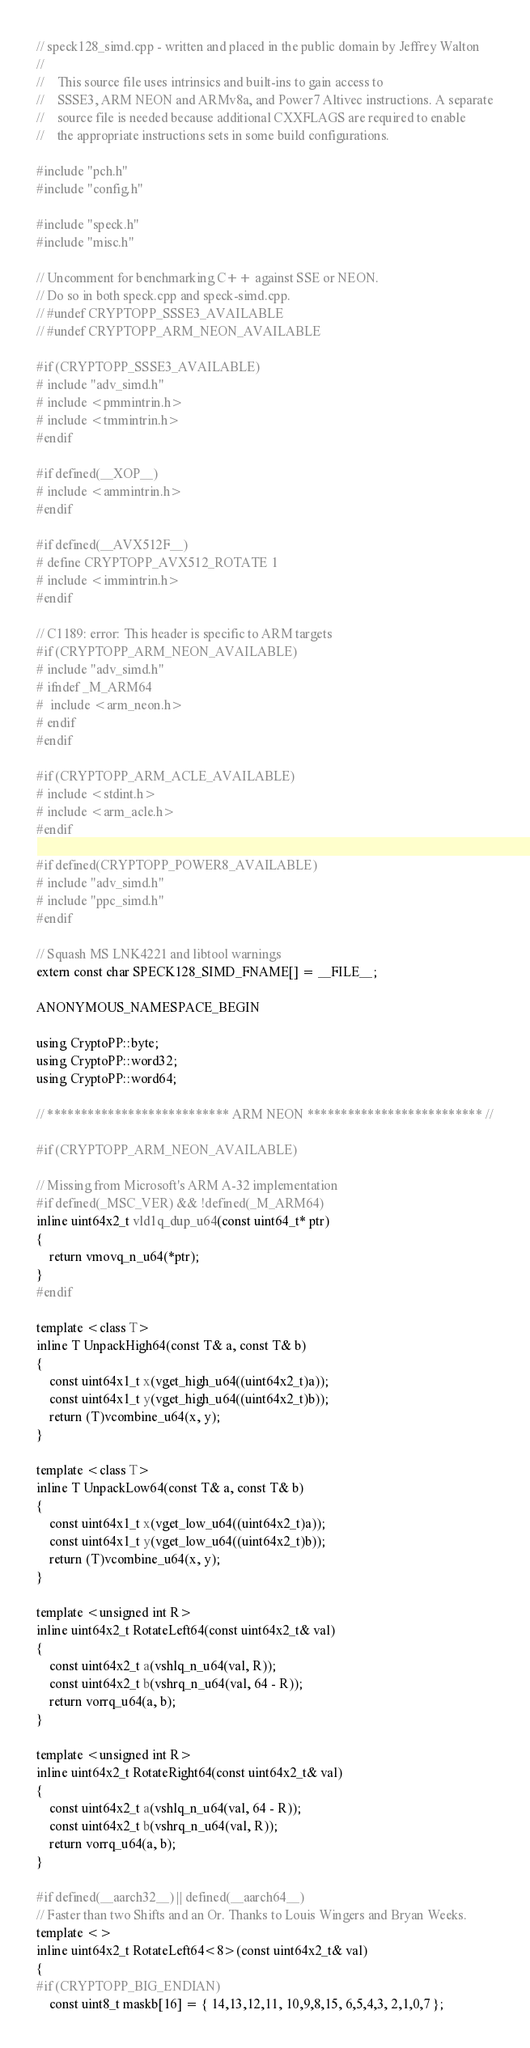<code> <loc_0><loc_0><loc_500><loc_500><_C++_>// speck128_simd.cpp - written and placed in the public domain by Jeffrey Walton
//
//    This source file uses intrinsics and built-ins to gain access to
//    SSSE3, ARM NEON and ARMv8a, and Power7 Altivec instructions. A separate
//    source file is needed because additional CXXFLAGS are required to enable
//    the appropriate instructions sets in some build configurations.

#include "pch.h"
#include "config.h"

#include "speck.h"
#include "misc.h"

// Uncomment for benchmarking C++ against SSE or NEON.
// Do so in both speck.cpp and speck-simd.cpp.
// #undef CRYPTOPP_SSSE3_AVAILABLE
// #undef CRYPTOPP_ARM_NEON_AVAILABLE

#if (CRYPTOPP_SSSE3_AVAILABLE)
# include "adv_simd.h"
# include <pmmintrin.h>
# include <tmmintrin.h>
#endif

#if defined(__XOP__)
# include <ammintrin.h>
#endif

#if defined(__AVX512F__)
# define CRYPTOPP_AVX512_ROTATE 1
# include <immintrin.h>
#endif

// C1189: error: This header is specific to ARM targets
#if (CRYPTOPP_ARM_NEON_AVAILABLE)
# include "adv_simd.h"
# ifndef _M_ARM64
#  include <arm_neon.h>
# endif
#endif

#if (CRYPTOPP_ARM_ACLE_AVAILABLE)
# include <stdint.h>
# include <arm_acle.h>
#endif

#if defined(CRYPTOPP_POWER8_AVAILABLE)
# include "adv_simd.h"
# include "ppc_simd.h"
#endif

// Squash MS LNK4221 and libtool warnings
extern const char SPECK128_SIMD_FNAME[] = __FILE__;

ANONYMOUS_NAMESPACE_BEGIN

using CryptoPP::byte;
using CryptoPP::word32;
using CryptoPP::word64;

// *************************** ARM NEON ************************** //

#if (CRYPTOPP_ARM_NEON_AVAILABLE)

// Missing from Microsoft's ARM A-32 implementation
#if defined(_MSC_VER) && !defined(_M_ARM64)
inline uint64x2_t vld1q_dup_u64(const uint64_t* ptr)
{
	return vmovq_n_u64(*ptr);
}
#endif

template <class T>
inline T UnpackHigh64(const T& a, const T& b)
{
    const uint64x1_t x(vget_high_u64((uint64x2_t)a));
    const uint64x1_t y(vget_high_u64((uint64x2_t)b));
    return (T)vcombine_u64(x, y);
}

template <class T>
inline T UnpackLow64(const T& a, const T& b)
{
    const uint64x1_t x(vget_low_u64((uint64x2_t)a));
    const uint64x1_t y(vget_low_u64((uint64x2_t)b));
    return (T)vcombine_u64(x, y);
}

template <unsigned int R>
inline uint64x2_t RotateLeft64(const uint64x2_t& val)
{
    const uint64x2_t a(vshlq_n_u64(val, R));
    const uint64x2_t b(vshrq_n_u64(val, 64 - R));
    return vorrq_u64(a, b);
}

template <unsigned int R>
inline uint64x2_t RotateRight64(const uint64x2_t& val)
{
    const uint64x2_t a(vshlq_n_u64(val, 64 - R));
    const uint64x2_t b(vshrq_n_u64(val, R));
    return vorrq_u64(a, b);
}

#if defined(__aarch32__) || defined(__aarch64__)
// Faster than two Shifts and an Or. Thanks to Louis Wingers and Bryan Weeks.
template <>
inline uint64x2_t RotateLeft64<8>(const uint64x2_t& val)
{
#if (CRYPTOPP_BIG_ENDIAN)
    const uint8_t maskb[16] = { 14,13,12,11, 10,9,8,15, 6,5,4,3, 2,1,0,7 };</code> 